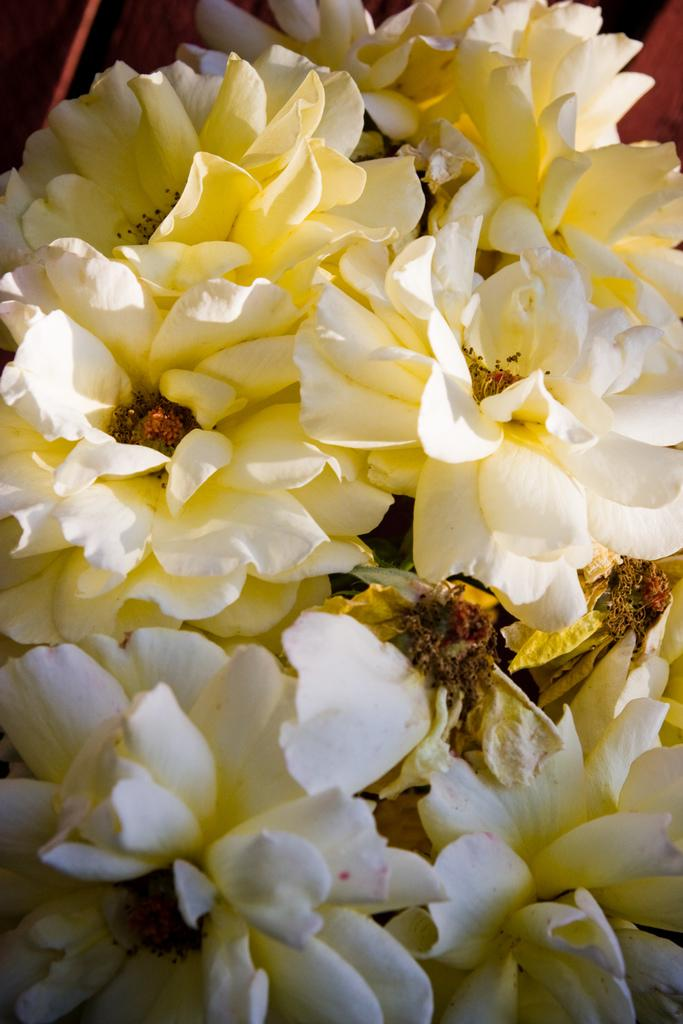What type of flowers can be seen in the image? There are white flowers in the image. What do the flowers resemble? The flowers resemble roses. How many fingers are visible on the flowers in the image? There are no fingers visible on the flowers in the image, as flowers do not have fingers. 